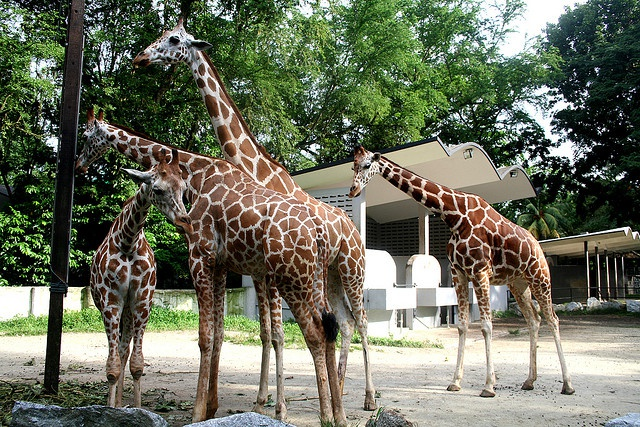Describe the objects in this image and their specific colors. I can see giraffe in lightgray, black, maroon, and gray tones, giraffe in lightgray, black, ivory, maroon, and darkgray tones, giraffe in lightgray, white, black, darkgray, and gray tones, and giraffe in lightgray, black, gray, darkgray, and maroon tones in this image. 